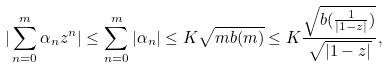<formula> <loc_0><loc_0><loc_500><loc_500>| \sum _ { n = 0 } ^ { m } \alpha _ { n } z ^ { n } | \leq \sum _ { n = 0 } ^ { m } | \alpha _ { n } | \leq K \sqrt { m b ( m ) } \leq K \frac { \sqrt { b ( \frac { 1 } { | 1 - z | } ) } } { \sqrt { | 1 - z | } } ,</formula> 